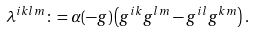Convert formula to latex. <formula><loc_0><loc_0><loc_500><loc_500>\lambda ^ { i k l m } \colon = \alpha ( - g ) \left ( g ^ { i k } g ^ { l m } - g ^ { i l } g ^ { k m } \right ) .</formula> 